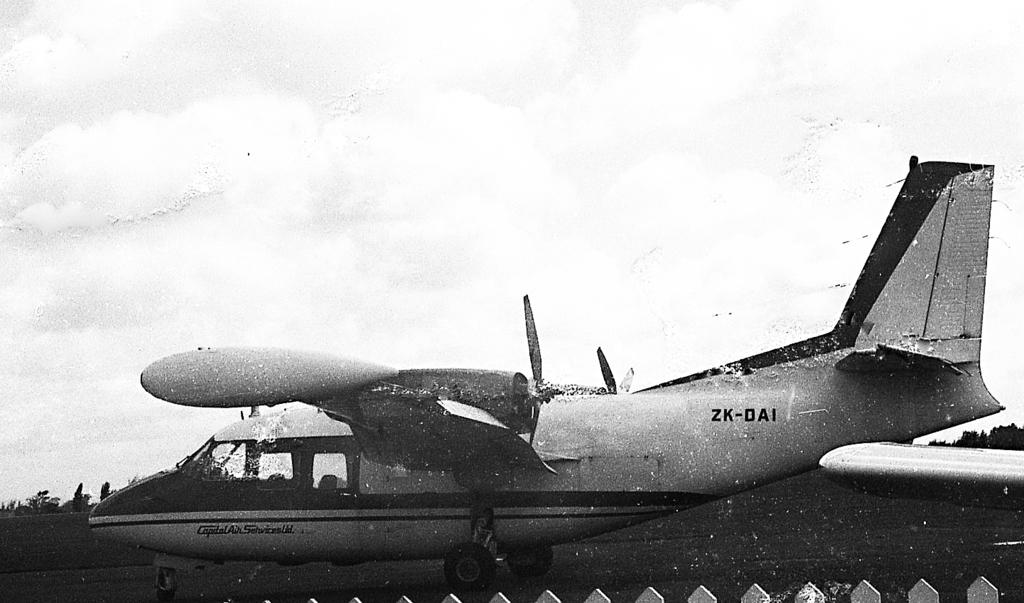What is the hull number?
Ensure brevity in your answer.  Zk-dai. 